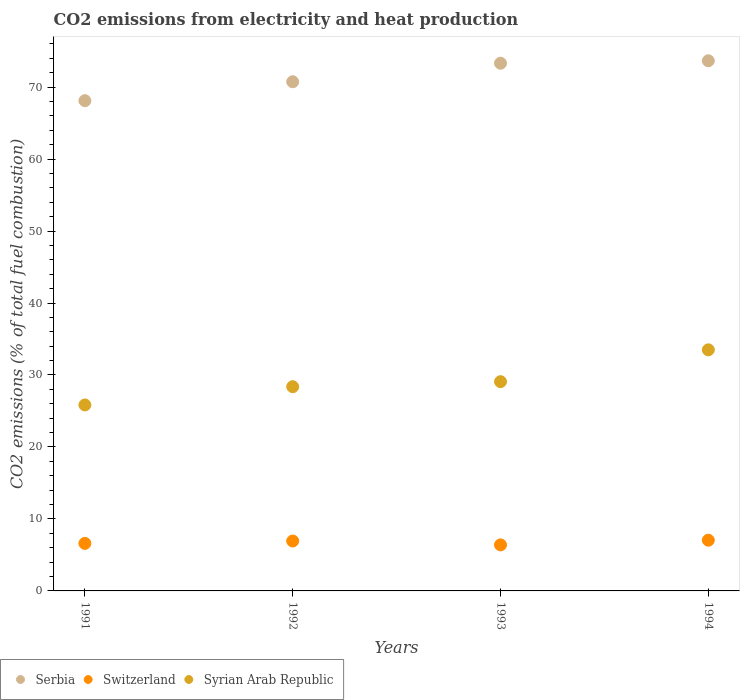How many different coloured dotlines are there?
Provide a succinct answer. 3. What is the amount of CO2 emitted in Serbia in 1994?
Keep it short and to the point. 73.65. Across all years, what is the maximum amount of CO2 emitted in Serbia?
Give a very brief answer. 73.65. Across all years, what is the minimum amount of CO2 emitted in Syrian Arab Republic?
Make the answer very short. 25.84. What is the total amount of CO2 emitted in Serbia in the graph?
Ensure brevity in your answer.  285.81. What is the difference between the amount of CO2 emitted in Switzerland in 1991 and that in 1992?
Offer a very short reply. -0.33. What is the difference between the amount of CO2 emitted in Syrian Arab Republic in 1991 and the amount of CO2 emitted in Switzerland in 1994?
Provide a short and direct response. 18.79. What is the average amount of CO2 emitted in Syrian Arab Republic per year?
Give a very brief answer. 29.19. In the year 1993, what is the difference between the amount of CO2 emitted in Syrian Arab Republic and amount of CO2 emitted in Switzerland?
Keep it short and to the point. 22.68. In how many years, is the amount of CO2 emitted in Serbia greater than 36 %?
Your answer should be very brief. 4. What is the ratio of the amount of CO2 emitted in Switzerland in 1991 to that in 1992?
Your answer should be compact. 0.95. What is the difference between the highest and the second highest amount of CO2 emitted in Serbia?
Provide a short and direct response. 0.34. What is the difference between the highest and the lowest amount of CO2 emitted in Serbia?
Offer a terse response. 5.54. Is it the case that in every year, the sum of the amount of CO2 emitted in Serbia and amount of CO2 emitted in Syrian Arab Republic  is greater than the amount of CO2 emitted in Switzerland?
Ensure brevity in your answer.  Yes. Does the graph contain grids?
Make the answer very short. No. How many legend labels are there?
Keep it short and to the point. 3. How are the legend labels stacked?
Ensure brevity in your answer.  Horizontal. What is the title of the graph?
Your answer should be compact. CO2 emissions from electricity and heat production. What is the label or title of the X-axis?
Keep it short and to the point. Years. What is the label or title of the Y-axis?
Your answer should be very brief. CO2 emissions (% of total fuel combustion). What is the CO2 emissions (% of total fuel combustion) in Serbia in 1991?
Offer a terse response. 68.11. What is the CO2 emissions (% of total fuel combustion) in Switzerland in 1991?
Your answer should be compact. 6.6. What is the CO2 emissions (% of total fuel combustion) in Syrian Arab Republic in 1991?
Your response must be concise. 25.84. What is the CO2 emissions (% of total fuel combustion) in Serbia in 1992?
Provide a succinct answer. 70.74. What is the CO2 emissions (% of total fuel combustion) of Switzerland in 1992?
Provide a short and direct response. 6.93. What is the CO2 emissions (% of total fuel combustion) in Syrian Arab Republic in 1992?
Make the answer very short. 28.37. What is the CO2 emissions (% of total fuel combustion) of Serbia in 1993?
Keep it short and to the point. 73.31. What is the CO2 emissions (% of total fuel combustion) of Switzerland in 1993?
Make the answer very short. 6.4. What is the CO2 emissions (% of total fuel combustion) of Syrian Arab Republic in 1993?
Offer a very short reply. 29.07. What is the CO2 emissions (% of total fuel combustion) of Serbia in 1994?
Offer a very short reply. 73.65. What is the CO2 emissions (% of total fuel combustion) of Switzerland in 1994?
Ensure brevity in your answer.  7.05. What is the CO2 emissions (% of total fuel combustion) of Syrian Arab Republic in 1994?
Keep it short and to the point. 33.49. Across all years, what is the maximum CO2 emissions (% of total fuel combustion) of Serbia?
Give a very brief answer. 73.65. Across all years, what is the maximum CO2 emissions (% of total fuel combustion) in Switzerland?
Your answer should be very brief. 7.05. Across all years, what is the maximum CO2 emissions (% of total fuel combustion) of Syrian Arab Republic?
Provide a short and direct response. 33.49. Across all years, what is the minimum CO2 emissions (% of total fuel combustion) in Serbia?
Provide a succinct answer. 68.11. Across all years, what is the minimum CO2 emissions (% of total fuel combustion) of Switzerland?
Your answer should be very brief. 6.4. Across all years, what is the minimum CO2 emissions (% of total fuel combustion) of Syrian Arab Republic?
Offer a very short reply. 25.84. What is the total CO2 emissions (% of total fuel combustion) in Serbia in the graph?
Your response must be concise. 285.81. What is the total CO2 emissions (% of total fuel combustion) in Switzerland in the graph?
Provide a succinct answer. 26.98. What is the total CO2 emissions (% of total fuel combustion) of Syrian Arab Republic in the graph?
Keep it short and to the point. 116.78. What is the difference between the CO2 emissions (% of total fuel combustion) in Serbia in 1991 and that in 1992?
Your answer should be compact. -2.63. What is the difference between the CO2 emissions (% of total fuel combustion) of Switzerland in 1991 and that in 1992?
Your answer should be very brief. -0.33. What is the difference between the CO2 emissions (% of total fuel combustion) of Syrian Arab Republic in 1991 and that in 1992?
Your response must be concise. -2.54. What is the difference between the CO2 emissions (% of total fuel combustion) in Serbia in 1991 and that in 1993?
Your answer should be compact. -5.2. What is the difference between the CO2 emissions (% of total fuel combustion) in Switzerland in 1991 and that in 1993?
Offer a very short reply. 0.21. What is the difference between the CO2 emissions (% of total fuel combustion) in Syrian Arab Republic in 1991 and that in 1993?
Offer a very short reply. -3.24. What is the difference between the CO2 emissions (% of total fuel combustion) of Serbia in 1991 and that in 1994?
Ensure brevity in your answer.  -5.54. What is the difference between the CO2 emissions (% of total fuel combustion) of Switzerland in 1991 and that in 1994?
Offer a very short reply. -0.44. What is the difference between the CO2 emissions (% of total fuel combustion) of Syrian Arab Republic in 1991 and that in 1994?
Give a very brief answer. -7.66. What is the difference between the CO2 emissions (% of total fuel combustion) in Serbia in 1992 and that in 1993?
Provide a succinct answer. -2.57. What is the difference between the CO2 emissions (% of total fuel combustion) in Switzerland in 1992 and that in 1993?
Make the answer very short. 0.54. What is the difference between the CO2 emissions (% of total fuel combustion) of Syrian Arab Republic in 1992 and that in 1993?
Provide a short and direct response. -0.7. What is the difference between the CO2 emissions (% of total fuel combustion) in Serbia in 1992 and that in 1994?
Provide a succinct answer. -2.91. What is the difference between the CO2 emissions (% of total fuel combustion) in Switzerland in 1992 and that in 1994?
Provide a short and direct response. -0.11. What is the difference between the CO2 emissions (% of total fuel combustion) of Syrian Arab Republic in 1992 and that in 1994?
Ensure brevity in your answer.  -5.12. What is the difference between the CO2 emissions (% of total fuel combustion) in Serbia in 1993 and that in 1994?
Offer a very short reply. -0.34. What is the difference between the CO2 emissions (% of total fuel combustion) of Switzerland in 1993 and that in 1994?
Provide a short and direct response. -0.65. What is the difference between the CO2 emissions (% of total fuel combustion) of Syrian Arab Republic in 1993 and that in 1994?
Provide a short and direct response. -4.42. What is the difference between the CO2 emissions (% of total fuel combustion) in Serbia in 1991 and the CO2 emissions (% of total fuel combustion) in Switzerland in 1992?
Your response must be concise. 61.18. What is the difference between the CO2 emissions (% of total fuel combustion) in Serbia in 1991 and the CO2 emissions (% of total fuel combustion) in Syrian Arab Republic in 1992?
Offer a terse response. 39.74. What is the difference between the CO2 emissions (% of total fuel combustion) in Switzerland in 1991 and the CO2 emissions (% of total fuel combustion) in Syrian Arab Republic in 1992?
Provide a succinct answer. -21.77. What is the difference between the CO2 emissions (% of total fuel combustion) in Serbia in 1991 and the CO2 emissions (% of total fuel combustion) in Switzerland in 1993?
Ensure brevity in your answer.  61.71. What is the difference between the CO2 emissions (% of total fuel combustion) in Serbia in 1991 and the CO2 emissions (% of total fuel combustion) in Syrian Arab Republic in 1993?
Make the answer very short. 39.04. What is the difference between the CO2 emissions (% of total fuel combustion) in Switzerland in 1991 and the CO2 emissions (% of total fuel combustion) in Syrian Arab Republic in 1993?
Ensure brevity in your answer.  -22.47. What is the difference between the CO2 emissions (% of total fuel combustion) in Serbia in 1991 and the CO2 emissions (% of total fuel combustion) in Switzerland in 1994?
Ensure brevity in your answer.  61.06. What is the difference between the CO2 emissions (% of total fuel combustion) of Serbia in 1991 and the CO2 emissions (% of total fuel combustion) of Syrian Arab Republic in 1994?
Offer a terse response. 34.61. What is the difference between the CO2 emissions (% of total fuel combustion) of Switzerland in 1991 and the CO2 emissions (% of total fuel combustion) of Syrian Arab Republic in 1994?
Provide a succinct answer. -26.89. What is the difference between the CO2 emissions (% of total fuel combustion) of Serbia in 1992 and the CO2 emissions (% of total fuel combustion) of Switzerland in 1993?
Your response must be concise. 64.34. What is the difference between the CO2 emissions (% of total fuel combustion) in Serbia in 1992 and the CO2 emissions (% of total fuel combustion) in Syrian Arab Republic in 1993?
Your answer should be compact. 41.67. What is the difference between the CO2 emissions (% of total fuel combustion) of Switzerland in 1992 and the CO2 emissions (% of total fuel combustion) of Syrian Arab Republic in 1993?
Keep it short and to the point. -22.14. What is the difference between the CO2 emissions (% of total fuel combustion) of Serbia in 1992 and the CO2 emissions (% of total fuel combustion) of Switzerland in 1994?
Your response must be concise. 63.7. What is the difference between the CO2 emissions (% of total fuel combustion) in Serbia in 1992 and the CO2 emissions (% of total fuel combustion) in Syrian Arab Republic in 1994?
Provide a short and direct response. 37.25. What is the difference between the CO2 emissions (% of total fuel combustion) of Switzerland in 1992 and the CO2 emissions (% of total fuel combustion) of Syrian Arab Republic in 1994?
Your answer should be compact. -26.56. What is the difference between the CO2 emissions (% of total fuel combustion) in Serbia in 1993 and the CO2 emissions (% of total fuel combustion) in Switzerland in 1994?
Provide a succinct answer. 66.27. What is the difference between the CO2 emissions (% of total fuel combustion) in Serbia in 1993 and the CO2 emissions (% of total fuel combustion) in Syrian Arab Republic in 1994?
Your answer should be compact. 39.82. What is the difference between the CO2 emissions (% of total fuel combustion) of Switzerland in 1993 and the CO2 emissions (% of total fuel combustion) of Syrian Arab Republic in 1994?
Offer a terse response. -27.1. What is the average CO2 emissions (% of total fuel combustion) in Serbia per year?
Provide a succinct answer. 71.45. What is the average CO2 emissions (% of total fuel combustion) of Switzerland per year?
Make the answer very short. 6.74. What is the average CO2 emissions (% of total fuel combustion) in Syrian Arab Republic per year?
Your response must be concise. 29.19. In the year 1991, what is the difference between the CO2 emissions (% of total fuel combustion) of Serbia and CO2 emissions (% of total fuel combustion) of Switzerland?
Your answer should be compact. 61.51. In the year 1991, what is the difference between the CO2 emissions (% of total fuel combustion) of Serbia and CO2 emissions (% of total fuel combustion) of Syrian Arab Republic?
Give a very brief answer. 42.27. In the year 1991, what is the difference between the CO2 emissions (% of total fuel combustion) in Switzerland and CO2 emissions (% of total fuel combustion) in Syrian Arab Republic?
Offer a very short reply. -19.23. In the year 1992, what is the difference between the CO2 emissions (% of total fuel combustion) in Serbia and CO2 emissions (% of total fuel combustion) in Switzerland?
Offer a terse response. 63.81. In the year 1992, what is the difference between the CO2 emissions (% of total fuel combustion) in Serbia and CO2 emissions (% of total fuel combustion) in Syrian Arab Republic?
Make the answer very short. 42.37. In the year 1992, what is the difference between the CO2 emissions (% of total fuel combustion) of Switzerland and CO2 emissions (% of total fuel combustion) of Syrian Arab Republic?
Give a very brief answer. -21.44. In the year 1993, what is the difference between the CO2 emissions (% of total fuel combustion) of Serbia and CO2 emissions (% of total fuel combustion) of Switzerland?
Keep it short and to the point. 66.92. In the year 1993, what is the difference between the CO2 emissions (% of total fuel combustion) in Serbia and CO2 emissions (% of total fuel combustion) in Syrian Arab Republic?
Give a very brief answer. 44.24. In the year 1993, what is the difference between the CO2 emissions (% of total fuel combustion) of Switzerland and CO2 emissions (% of total fuel combustion) of Syrian Arab Republic?
Your answer should be compact. -22.68. In the year 1994, what is the difference between the CO2 emissions (% of total fuel combustion) of Serbia and CO2 emissions (% of total fuel combustion) of Switzerland?
Your response must be concise. 66.61. In the year 1994, what is the difference between the CO2 emissions (% of total fuel combustion) of Serbia and CO2 emissions (% of total fuel combustion) of Syrian Arab Republic?
Your answer should be very brief. 40.16. In the year 1994, what is the difference between the CO2 emissions (% of total fuel combustion) of Switzerland and CO2 emissions (% of total fuel combustion) of Syrian Arab Republic?
Make the answer very short. -26.45. What is the ratio of the CO2 emissions (% of total fuel combustion) of Serbia in 1991 to that in 1992?
Provide a short and direct response. 0.96. What is the ratio of the CO2 emissions (% of total fuel combustion) in Switzerland in 1991 to that in 1992?
Your answer should be very brief. 0.95. What is the ratio of the CO2 emissions (% of total fuel combustion) in Syrian Arab Republic in 1991 to that in 1992?
Keep it short and to the point. 0.91. What is the ratio of the CO2 emissions (% of total fuel combustion) in Serbia in 1991 to that in 1993?
Make the answer very short. 0.93. What is the ratio of the CO2 emissions (% of total fuel combustion) in Switzerland in 1991 to that in 1993?
Provide a succinct answer. 1.03. What is the ratio of the CO2 emissions (% of total fuel combustion) of Syrian Arab Republic in 1991 to that in 1993?
Keep it short and to the point. 0.89. What is the ratio of the CO2 emissions (% of total fuel combustion) in Serbia in 1991 to that in 1994?
Ensure brevity in your answer.  0.92. What is the ratio of the CO2 emissions (% of total fuel combustion) in Switzerland in 1991 to that in 1994?
Offer a very short reply. 0.94. What is the ratio of the CO2 emissions (% of total fuel combustion) of Syrian Arab Republic in 1991 to that in 1994?
Provide a short and direct response. 0.77. What is the ratio of the CO2 emissions (% of total fuel combustion) in Serbia in 1992 to that in 1993?
Offer a terse response. 0.96. What is the ratio of the CO2 emissions (% of total fuel combustion) of Switzerland in 1992 to that in 1993?
Provide a short and direct response. 1.08. What is the ratio of the CO2 emissions (% of total fuel combustion) of Syrian Arab Republic in 1992 to that in 1993?
Offer a very short reply. 0.98. What is the ratio of the CO2 emissions (% of total fuel combustion) of Serbia in 1992 to that in 1994?
Make the answer very short. 0.96. What is the ratio of the CO2 emissions (% of total fuel combustion) of Switzerland in 1992 to that in 1994?
Make the answer very short. 0.98. What is the ratio of the CO2 emissions (% of total fuel combustion) in Syrian Arab Republic in 1992 to that in 1994?
Offer a terse response. 0.85. What is the ratio of the CO2 emissions (% of total fuel combustion) in Serbia in 1993 to that in 1994?
Keep it short and to the point. 1. What is the ratio of the CO2 emissions (% of total fuel combustion) of Switzerland in 1993 to that in 1994?
Offer a terse response. 0.91. What is the ratio of the CO2 emissions (% of total fuel combustion) of Syrian Arab Republic in 1993 to that in 1994?
Keep it short and to the point. 0.87. What is the difference between the highest and the second highest CO2 emissions (% of total fuel combustion) in Serbia?
Provide a succinct answer. 0.34. What is the difference between the highest and the second highest CO2 emissions (% of total fuel combustion) of Switzerland?
Offer a very short reply. 0.11. What is the difference between the highest and the second highest CO2 emissions (% of total fuel combustion) in Syrian Arab Republic?
Provide a succinct answer. 4.42. What is the difference between the highest and the lowest CO2 emissions (% of total fuel combustion) in Serbia?
Ensure brevity in your answer.  5.54. What is the difference between the highest and the lowest CO2 emissions (% of total fuel combustion) in Switzerland?
Offer a very short reply. 0.65. What is the difference between the highest and the lowest CO2 emissions (% of total fuel combustion) in Syrian Arab Republic?
Give a very brief answer. 7.66. 